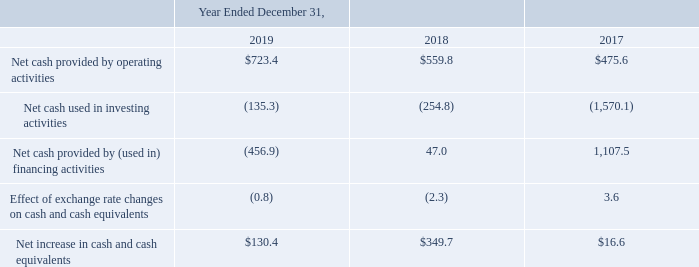Cash Flows
The following table summarizes our cash flows for the periods indicated:
Operating Activities
Our primary source of cash from operating activities has been cash collections from our customers. We expect cash inflows from operating activities to be primarily affected by increases in total bookings. Our primary uses of cash from operating activities have been for domain registration costs paid to registries, software licensing fees related to third-party email and productivity solutions, personnel costs, discretionary marketing and advertising costs, technology and development costs and interest payments. We expect cash outflows from operating activities to be affected by the timing of payments we make to registries and increases in personnel and other operating costs as we continue to grow our business and increase our international presence.
Net cash provided by operating activities increased $163.6 million from $559.8 million in 2018 to $723.4 million in 2019, primarily driven by our bookings growth as well as increased interest income.
Investing Activities
Our investing activities primarily consist of strategic acquisitions and purchases of property and equipment to support the overall growth of our business and our increased international presence. We expect our investing cash flows to be affected by the timing of payments we make for capital expenditures and the strategic acquisition or other growth opportunities we decide to pursue.
Net cash used in investing activities decreased $119.5 million from $254.8 million in 2018 to $135.3 million in 2019, primarily due to a $106.9 million decrease in business acquisitions.
Financing Activities
Our financing activities primarily consist of long-term debt borrowings, the repayment of principal on long-term debt, stock option exercises and share repurchases.
Net cash from financing activities decreased $503.9 million from $47.0 million provided in 2018 to $456.9 million used in 2019, primarily resulting from $458.6 million of share repurchases in 2019, a $44.4 million increase in acquisition contingent consideration payments and $13.2 million of financing-related costs paid in 2019.
What are the 3 types of activities that cash flow comprises of? Operating, investing, financing. What is the net cash provided by operating activities for year ended 2019?
Answer scale should be: million. $723.4. What is the net cash provided by operating activities for year ended 2018?
Answer scale should be: million. $559.8. What is the average net cash provided by operating activities for 2018 and 2019?
Answer scale should be: million. (723.4+559.8)/2
Answer: 641.6. Between 2018 and 2019, which year has the highest Net increase in cash and cash equivalents? 349.7> 130.4
Answer: 2018. Which year has the highest Net cash provided by operating activities? 723.4> 559.8> 475.6
Answer: 2019. 